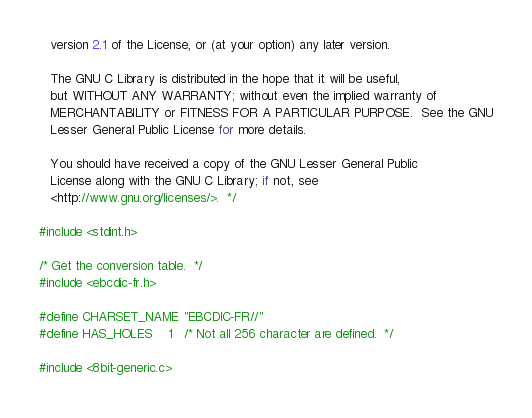<code> <loc_0><loc_0><loc_500><loc_500><_C_>   version 2.1 of the License, or (at your option) any later version.

   The GNU C Library is distributed in the hope that it will be useful,
   but WITHOUT ANY WARRANTY; without even the implied warranty of
   MERCHANTABILITY or FITNESS FOR A PARTICULAR PURPOSE.  See the GNU
   Lesser General Public License for more details.

   You should have received a copy of the GNU Lesser General Public
   License along with the GNU C Library; if not, see
   <http://www.gnu.org/licenses/>.  */

#include <stdint.h>

/* Get the conversion table.  */
#include <ebcdic-fr.h>

#define CHARSET_NAME	"EBCDIC-FR//"
#define HAS_HOLES	1	/* Not all 256 character are defined.  */

#include <8bit-generic.c>
</code> 